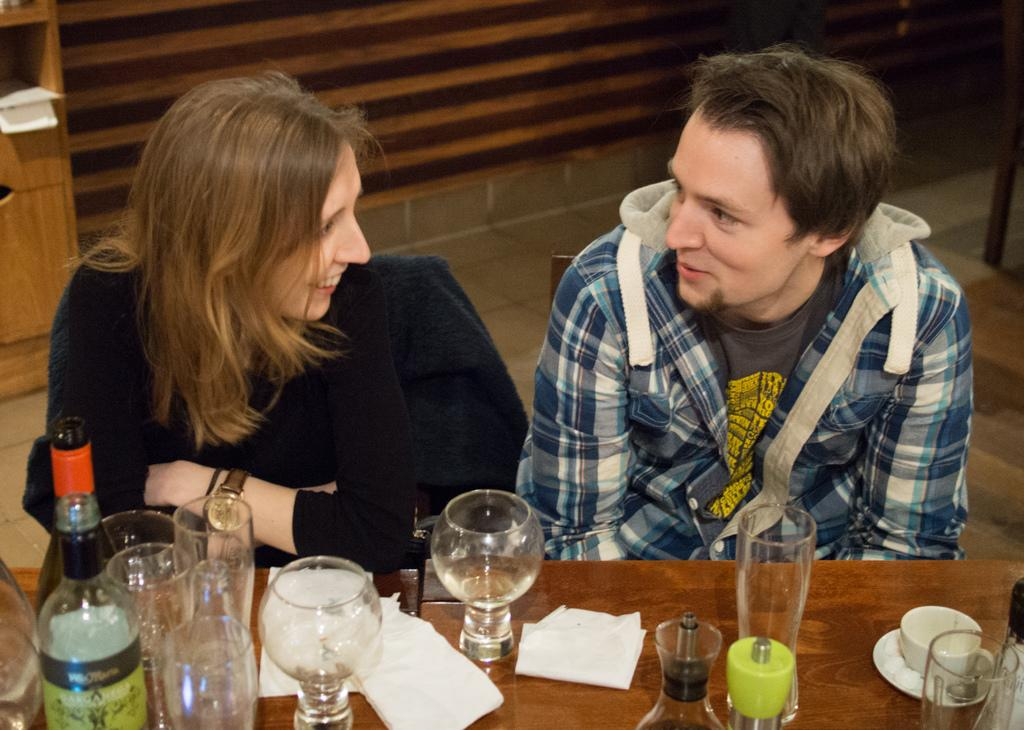How many people are present in the image? There are two people, a man and a woman, present in the image. What are the man and woman doing in the image? Both the man and woman are sitting on a chair. What objects can be seen on the table in the image? There is a bottle, a cup, a saucer, a paper, and a glass on the table. How many children are playing in the quicksand in the image? There are no children or quicksand present in the image. 